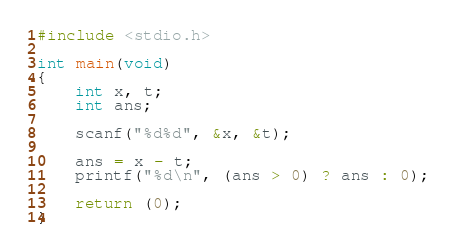Convert code to text. <code><loc_0><loc_0><loc_500><loc_500><_C_>#include <stdio.h>

int main(void)
{
	int x, t;
	int ans;

	scanf("%d%d", &x, &t);

	ans = x - t;
	printf("%d\n", (ans > 0) ? ans : 0);

	return (0);
}</code> 